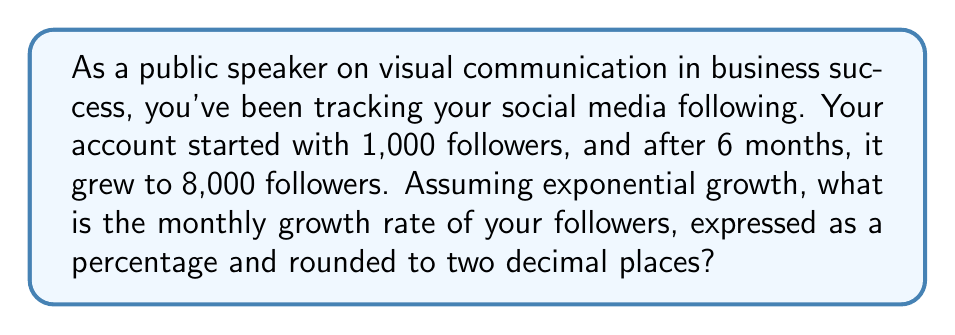Can you answer this question? Let's approach this step-by-step:

1) The exponential growth formula is:
   $A = P(1 + r)^t$
   Where:
   $A$ = final amount
   $P$ = initial amount
   $r$ = growth rate (in decimal form)
   $t$ = time period

2) We know:
   $P = 1,000$ (initial followers)
   $A = 8,000$ (final followers)
   $t = 6$ (months)

3) Let's plug these into our formula:
   $8,000 = 1,000(1 + r)^6$

4) Divide both sides by 1,000:
   $8 = (1 + r)^6$

5) Take the 6th root of both sides:
   $\sqrt[6]{8} = 1 + r$

6) Solve for $r$:
   $r = \sqrt[6]{8} - 1$

7) Calculate this value:
   $r \approx 1.4142135624 - 1 = 0.4142135624$

8) Convert to a percentage by multiplying by 100:
   $0.4142135624 * 100 \approx 41.42\%$

9) Rounding to two decimal places:
   $41.42\%$

This means your followers are growing by approximately 41.42% each month.
Answer: 41.42% 